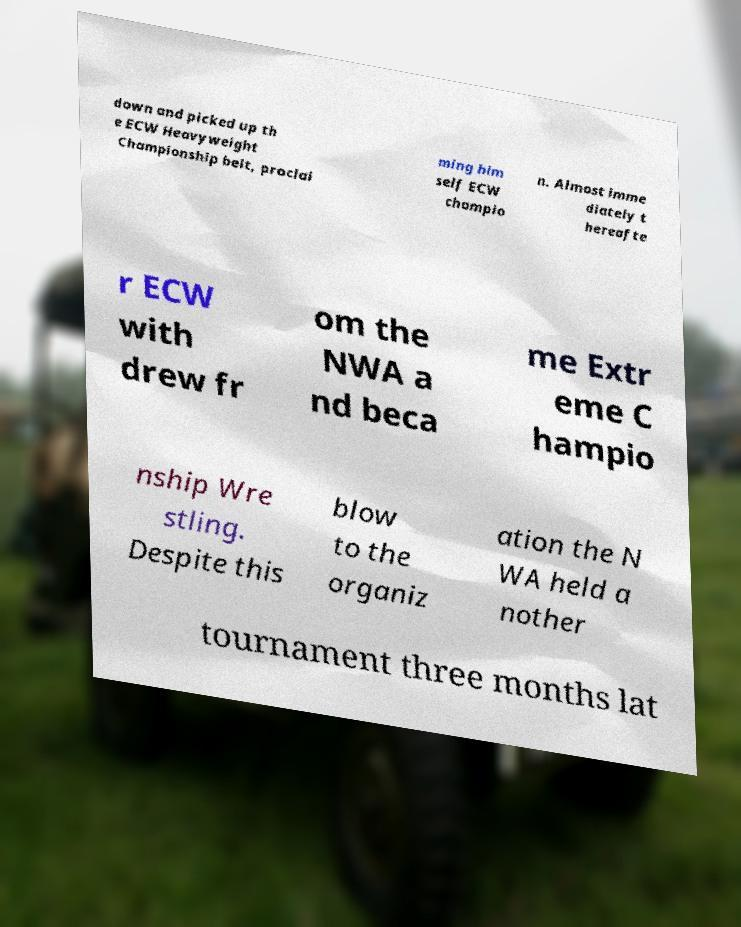I need the written content from this picture converted into text. Can you do that? down and picked up th e ECW Heavyweight Championship belt, proclai ming him self ECW champio n. Almost imme diately t hereafte r ECW with drew fr om the NWA a nd beca me Extr eme C hampio nship Wre stling. Despite this blow to the organiz ation the N WA held a nother tournament three months lat 